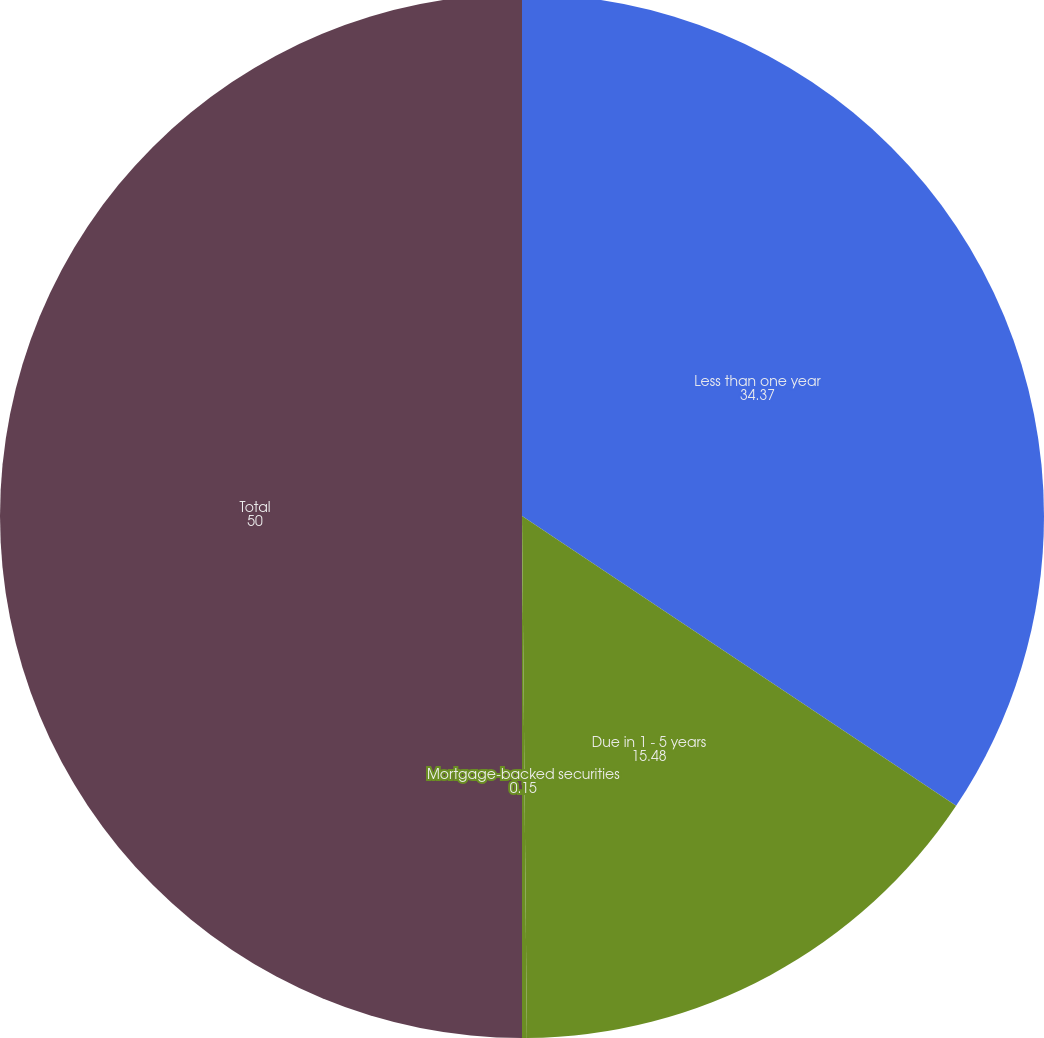<chart> <loc_0><loc_0><loc_500><loc_500><pie_chart><fcel>Less than one year<fcel>Due in 1 - 5 years<fcel>Mortgage-backed securities<fcel>Total<nl><fcel>34.37%<fcel>15.48%<fcel>0.15%<fcel>50.0%<nl></chart> 